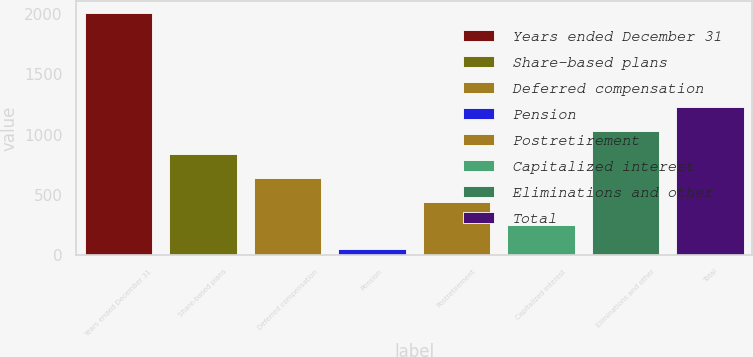<chart> <loc_0><loc_0><loc_500><loc_500><bar_chart><fcel>Years ended December 31<fcel>Share-based plans<fcel>Deferred compensation<fcel>Pension<fcel>Postretirement<fcel>Capitalized interest<fcel>Eliminations and other<fcel>Total<nl><fcel>2010<fcel>836.4<fcel>640.8<fcel>54<fcel>445.2<fcel>249.6<fcel>1032<fcel>1227.6<nl></chart> 